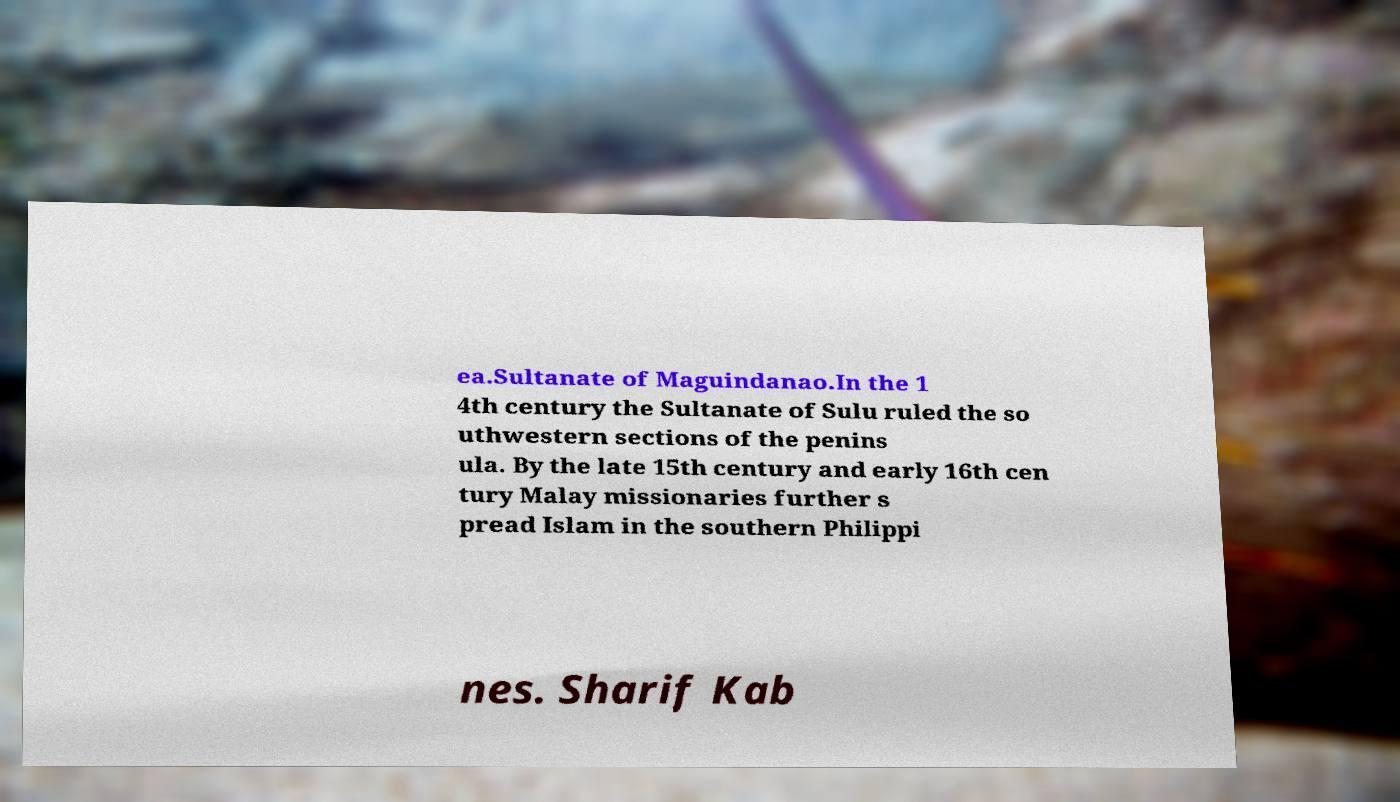I need the written content from this picture converted into text. Can you do that? ea.Sultanate of Maguindanao.In the 1 4th century the Sultanate of Sulu ruled the so uthwestern sections of the penins ula. By the late 15th century and early 16th cen tury Malay missionaries further s pread Islam in the southern Philippi nes. Sharif Kab 